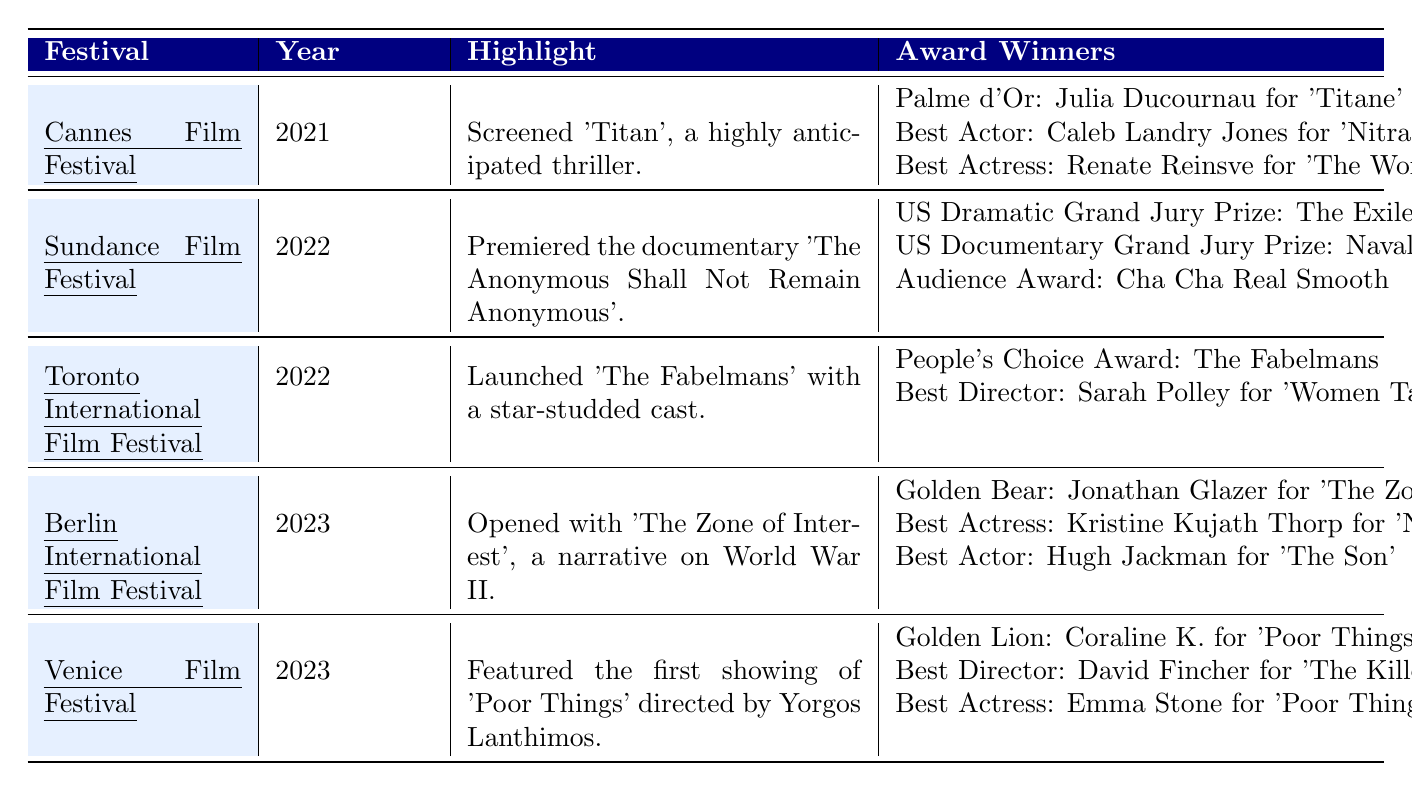What film was awarded the Palme d'Or at the Cannes Film Festival in 2021? The table indicates that the Palme d'Or was awarded to Julia Ducournau for the film 'Titane' at the Cannes Film Festival in 2021.
Answer: 'Titane' Which film won the Best Director award at the Toronto International Film Festival in 2022? According to the table, Sarah Polley for 'Women Talking' won the Best Director award at the Toronto International Film Festival in 2022.
Answer: 'Women Talking' Did any film win multiple awards at the Venice Film Festival in 2023? The table shows that at the Venice Film Festival in 2023, 'Poor Things' won both the Golden Lion and Best Actress awards (for Emma Stone), meaning it won multiple awards.
Answer: Yes What is the total number of awards won by 'The Zone of Interest' at the Berlin International Film Festival in 2023? The table states that 'The Zone of Interest' won the Golden Bear (1), and Hugh Jackman won Best Actor, totaling 2 awards. Thus, adding 1 for Best Actress (Kristine Kujath Thorp for 'Ninjababy') results in a total of 3 awards related to this film.
Answer: 2 Which festival had the most award categories listed and how many? Examining the festival entries in the table, the Venice Film Festival has 3 award categories listed: Golden Lion, Best Director, and Best Actress. This is more than any other festival listed, which had fewer categories.
Answer: 3 Name the winner of Best Actor across all festivals listed. The table displays that Caleb Landry Jones won Best Actor at the Cannes Film Festival in 2021 and Hugh Jackman at the Berlin International Film Festival in 2023. Thus, there are two different winners.
Answer: Caleb Landry Jones and Hugh Jackman How many different festivals were highlighted in the table? The table lists 5 different festivals: Cannes, Sundance, Toronto, Berlin, and Venice, by counting each uniquely mentioned festival name.
Answer: 5 Was 'The Fabelmans' featured as a highlight at any festival? The table shows that 'The Fabelmans' was specifically highlighted at the Toronto International Film Festival in 2022.
Answer: Yes 